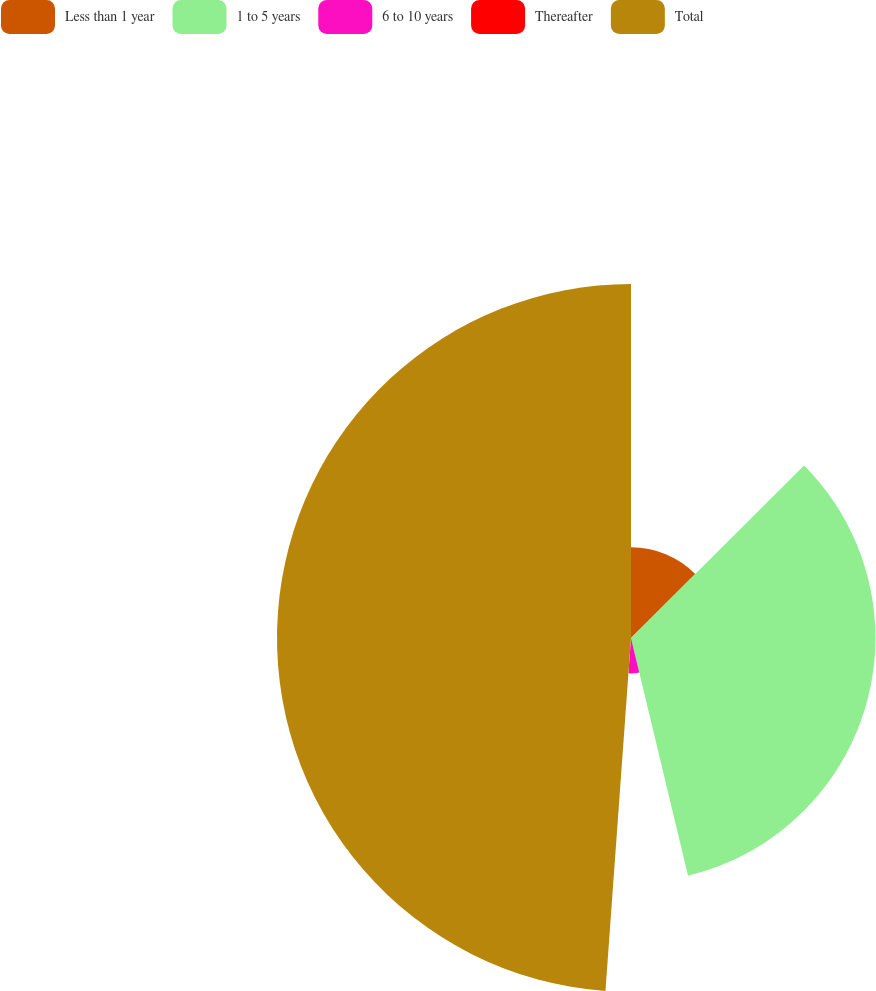Convert chart to OTSL. <chart><loc_0><loc_0><loc_500><loc_500><pie_chart><fcel>Less than 1 year<fcel>1 to 5 years<fcel>6 to 10 years<fcel>Thereafter<fcel>Total<nl><fcel>12.52%<fcel>33.73%<fcel>4.89%<fcel>0.01%<fcel>48.85%<nl></chart> 